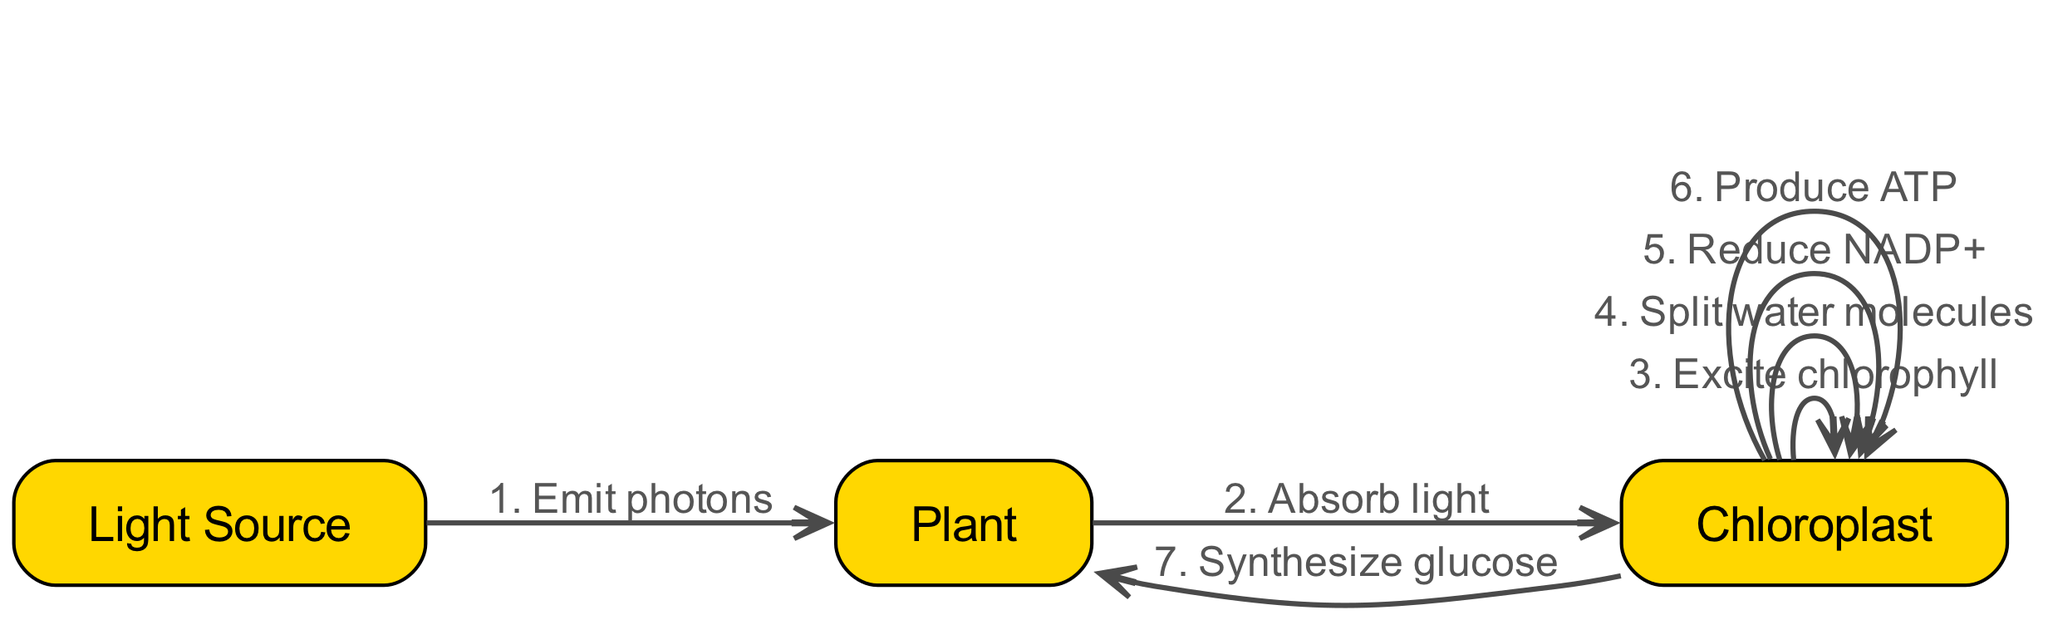What are the actors involved in the photosynthesis process? The diagram indicates three actors: Light Source, Plant, and Chloroplast. These actors represent the key components involved in the photosynthesis process.
Answer: Light Source, Plant, Chloroplast How many actions occur in total within the chloroplast? By observing the diagram, there are five actions that occur within the chloroplast: Excite chlorophyll, Split water molecules, Reduce NADP+, Produce ATP, and Synthesize glucose. Thus, the total count of actions is five.
Answer: Five What is the first action listed in the sequence of photosynthesis? The sequence begins with the action "Emit photons" originating from the Light Source and directed towards the Plant. Hence, the first action is to emit photons.
Answer: Emit photons Which actor absorbs light during photosynthesis? The diagram clearly shows that the Plant acts to absorb light, following the emission of photons from the Light Source. Hence, the answer is Plant.
Answer: Plant What is the last action that takes place according to the diagram? Following the sequence of actions, the final action indicated is "Synthesize glucose" occurring from the Chloroplast to the Plant. Thus, the last action in the diagram is synthesizing glucose.
Answer: Synthesize glucose How many total sequences are represented in the diagram? There are a total of six sequences represented in the diagram, each highlighting the flow of actions from one actor to another. The total series of sequences provides an overview of the entire photosynthesis process.
Answer: Six What is the relationship between the Light Source and the Plant in the photosynthesis process? The diagram illustrates the relationship as a directional flow where the Light Source emits photons to the Plant. This shows that the Plant receives light energy from the Light Source.
Answer: Emit photons Which molecule is reduced in the chloroplast during photosynthesis? The diagram specifies that NADP+ is reduced within the chloroplast, highlighting its significant role in the photosynthesis process. Thus, the reduced molecule is NADP+.
Answer: NADP+ What action immediately follows the "Excite chlorophyll" step in photosynthesis? Within the sequence of actions, "Split water molecules" follows directly after "Excite chlorophyll," indicating this is the subsequent step in the photosynthesis process.
Answer: Split water molecules 